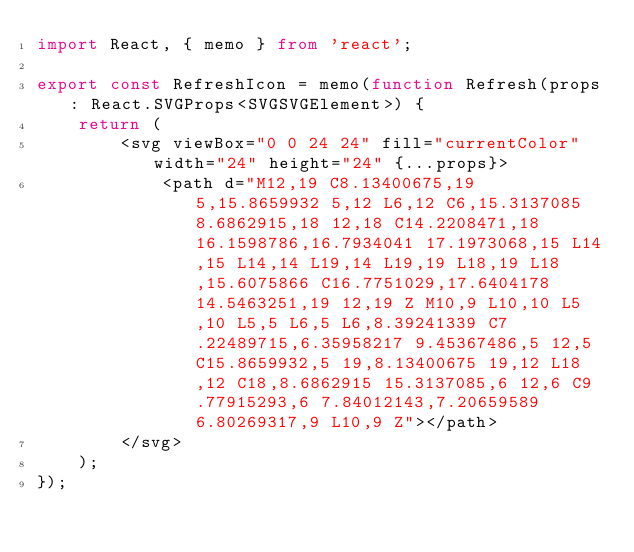<code> <loc_0><loc_0><loc_500><loc_500><_TypeScript_>import React, { memo } from 'react';

export const RefreshIcon = memo(function Refresh(props: React.SVGProps<SVGSVGElement>) {
    return (
        <svg viewBox="0 0 24 24" fill="currentColor" width="24" height="24" {...props}>
            <path d="M12,19 C8.13400675,19 5,15.8659932 5,12 L6,12 C6,15.3137085 8.6862915,18 12,18 C14.2208471,18 16.1598786,16.7934041 17.1973068,15 L14,15 L14,14 L19,14 L19,19 L18,19 L18,15.6075866 C16.7751029,17.6404178 14.5463251,19 12,19 Z M10,9 L10,10 L5,10 L5,5 L6,5 L6,8.39241339 C7.22489715,6.35958217 9.45367486,5 12,5 C15.8659932,5 19,8.13400675 19,12 L18,12 C18,8.6862915 15.3137085,6 12,6 C9.77915293,6 7.84012143,7.20659589 6.80269317,9 L10,9 Z"></path>
        </svg>
    );
});
</code> 